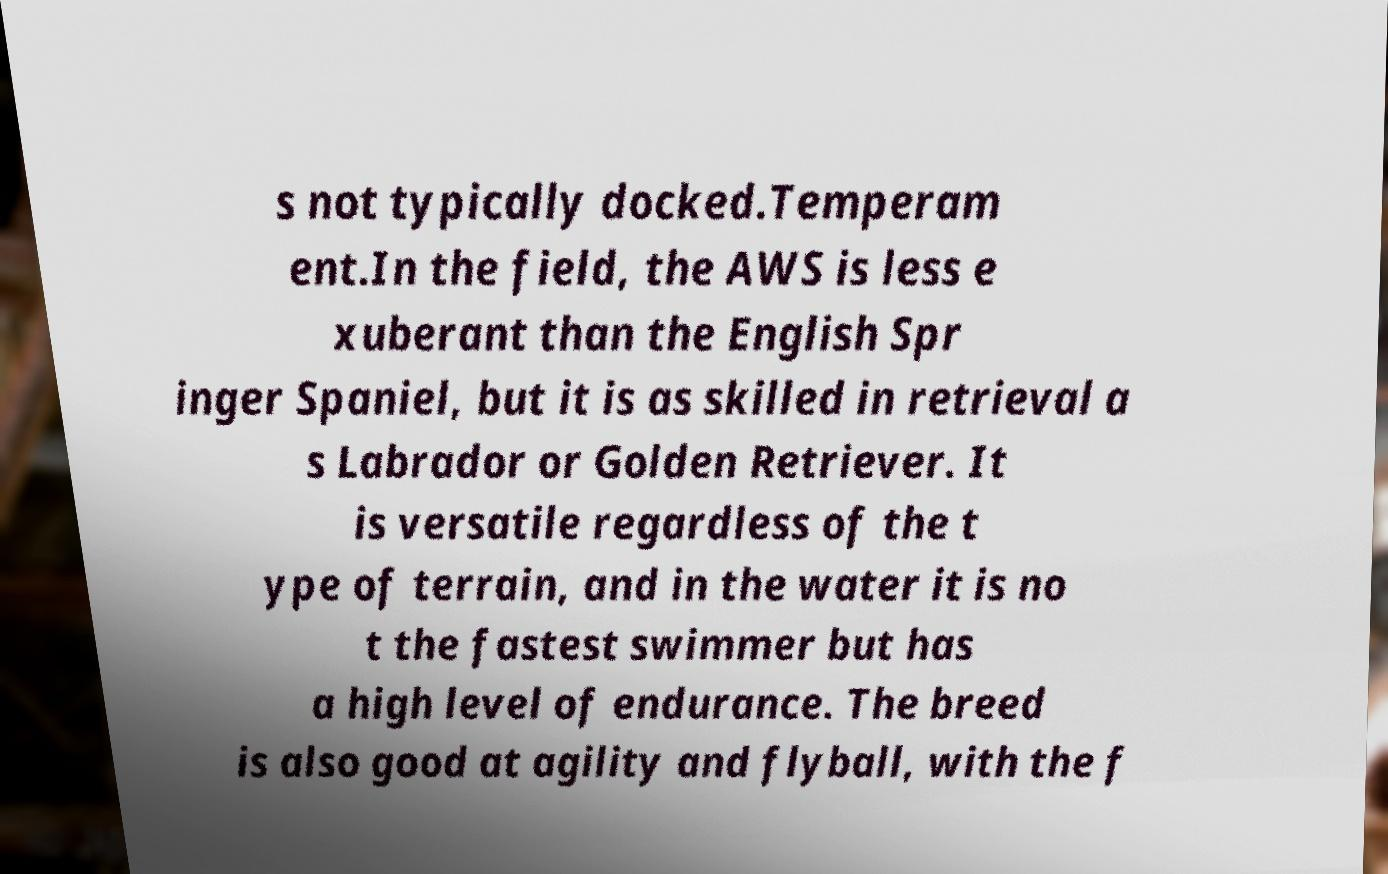Please identify and transcribe the text found in this image. s not typically docked.Temperam ent.In the field, the AWS is less e xuberant than the English Spr inger Spaniel, but it is as skilled in retrieval a s Labrador or Golden Retriever. It is versatile regardless of the t ype of terrain, and in the water it is no t the fastest swimmer but has a high level of endurance. The breed is also good at agility and flyball, with the f 